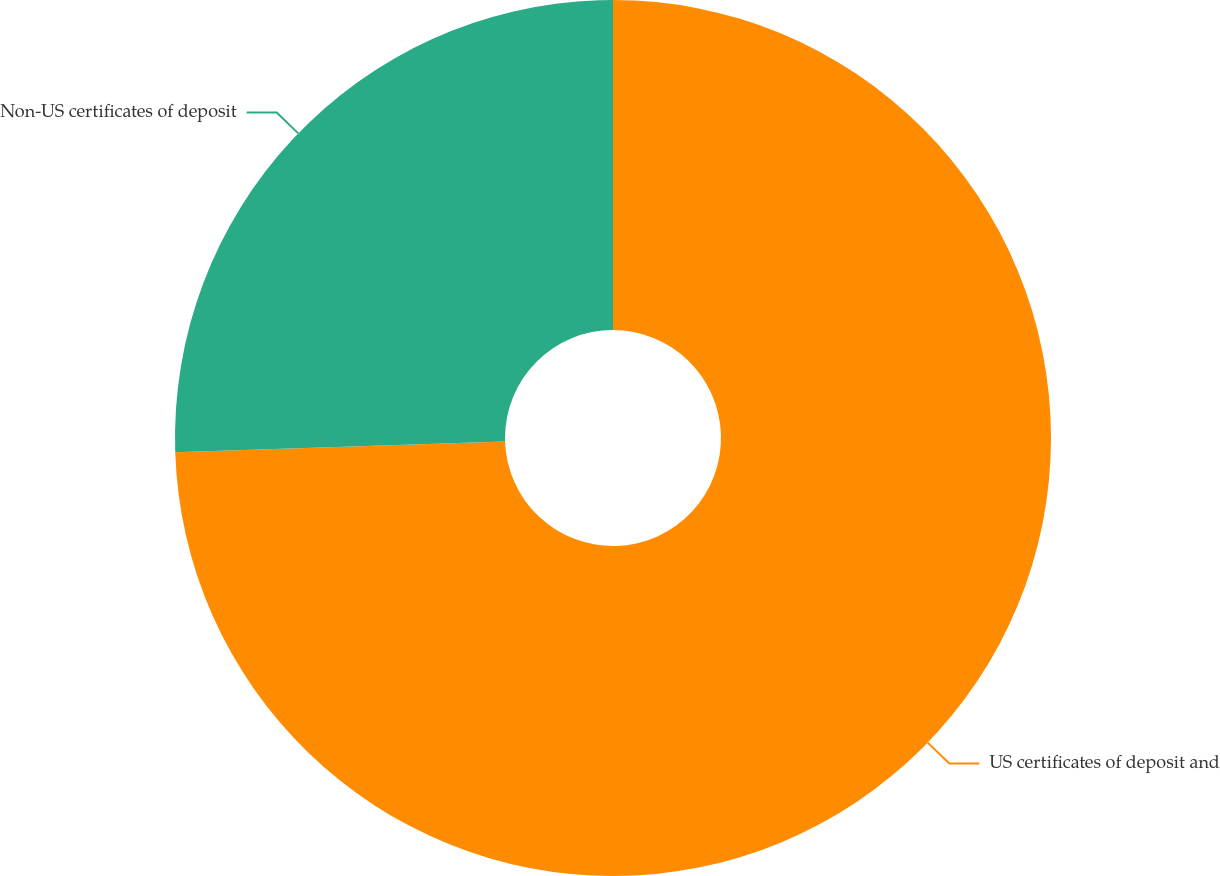Convert chart. <chart><loc_0><loc_0><loc_500><loc_500><pie_chart><fcel>US certificates of deposit and<fcel>Non-US certificates of deposit<nl><fcel>74.48%<fcel>25.52%<nl></chart> 